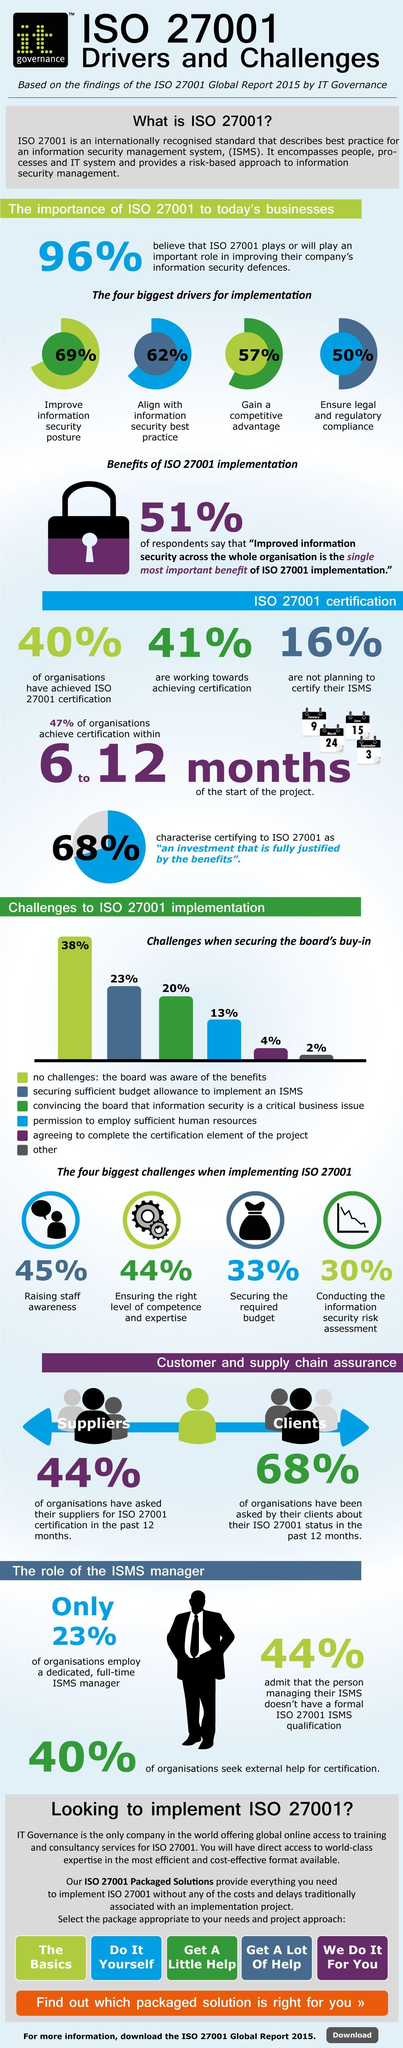What percentage of organizations are working towards achieving certification?
Answer the question with a short phrase. 41% What percentage of organizations didn't employ a dedicated, full-time ISMS manager? 77% What percentage of organizations didn't seek external help for certification? 60% 